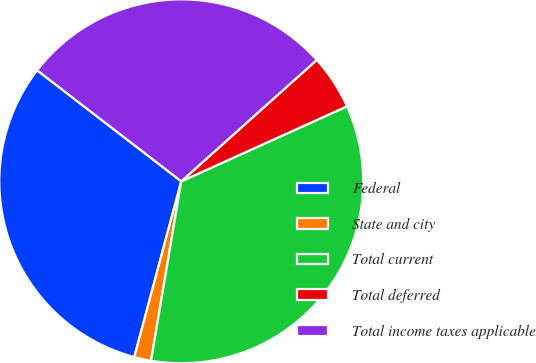<chart> <loc_0><loc_0><loc_500><loc_500><pie_chart><fcel>Federal<fcel>State and city<fcel>Total current<fcel>Total deferred<fcel>Total income taxes applicable<nl><fcel>31.29%<fcel>1.5%<fcel>34.42%<fcel>4.86%<fcel>27.93%<nl></chart> 